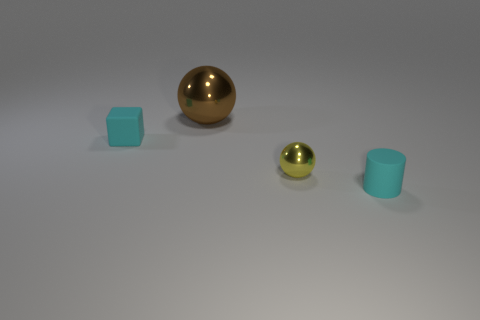Add 1 small purple matte cylinders. How many objects exist? 5 Subtract all cylinders. How many objects are left? 3 Add 3 yellow things. How many yellow things exist? 4 Subtract 0 yellow cylinders. How many objects are left? 4 Subtract all large blue matte blocks. Subtract all tiny yellow shiny things. How many objects are left? 3 Add 4 cyan rubber things. How many cyan rubber things are left? 6 